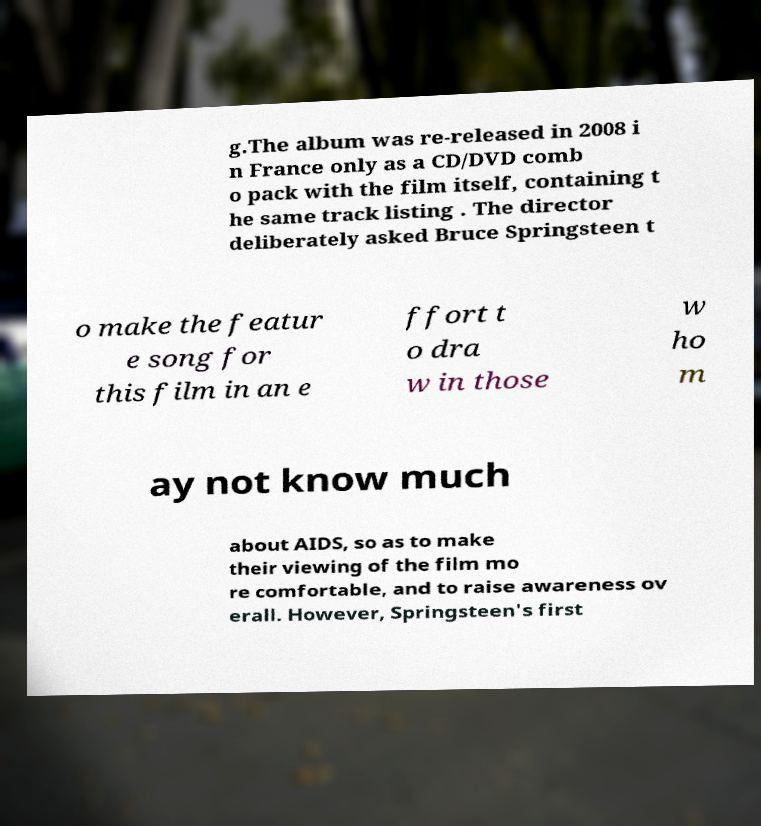Could you assist in decoding the text presented in this image and type it out clearly? g.The album was re-released in 2008 i n France only as a CD/DVD comb o pack with the film itself, containing t he same track listing . The director deliberately asked Bruce Springsteen t o make the featur e song for this film in an e ffort t o dra w in those w ho m ay not know much about AIDS, so as to make their viewing of the film mo re comfortable, and to raise awareness ov erall. However, Springsteen's first 